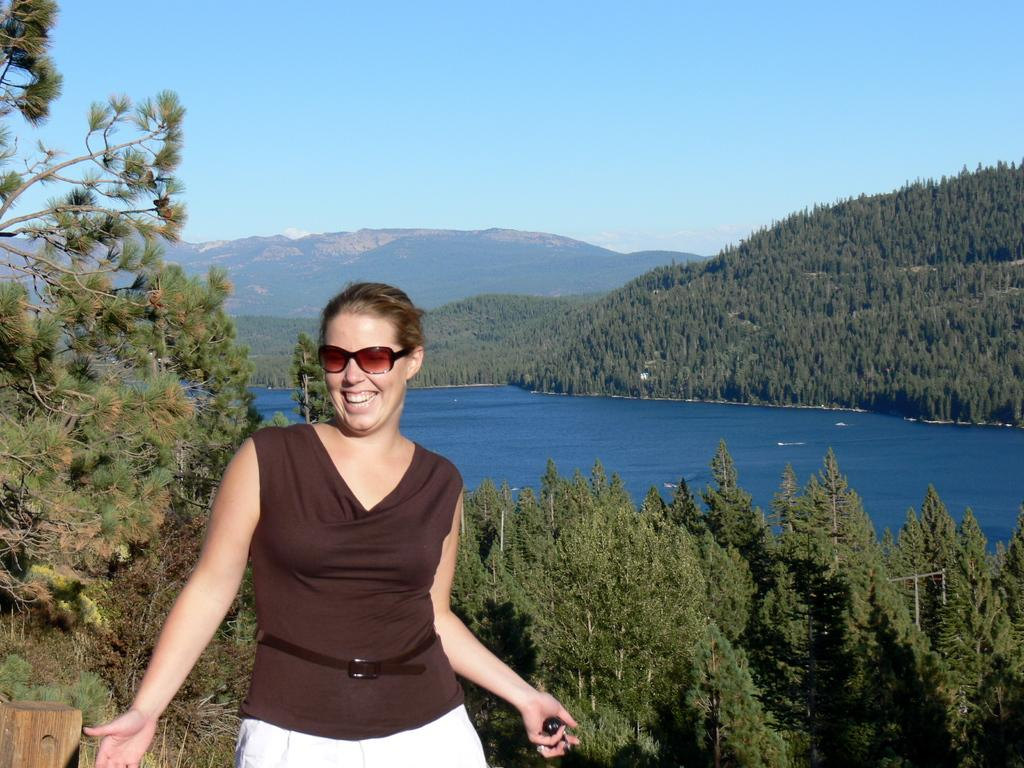What is the main subject in the foreground of the image? There is a woman in the foreground of the image. What is the woman doing in the image? The woman is laughing. What can be seen in the background of the image? There are trees, a water surface, and mountains visible in the background of the image. What type of cream is being distributed by the waves in the image? There are no waves or cream present in the image. 